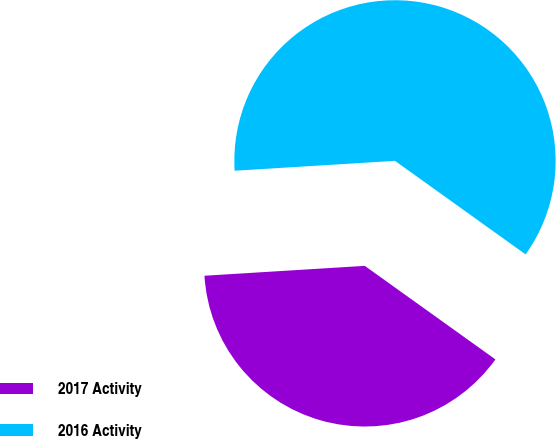<chart> <loc_0><loc_0><loc_500><loc_500><pie_chart><fcel>2017 Activity<fcel>2016 Activity<nl><fcel>39.13%<fcel>60.87%<nl></chart> 